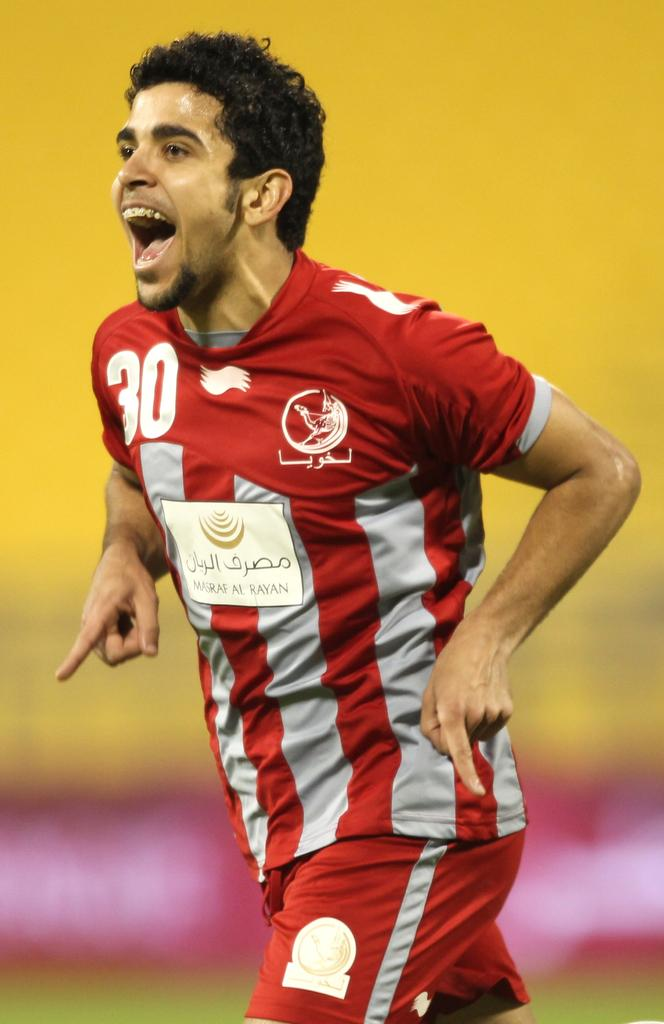<image>
Relay a brief, clear account of the picture shown. A man is wearing a uniform with the number 30 on it. 